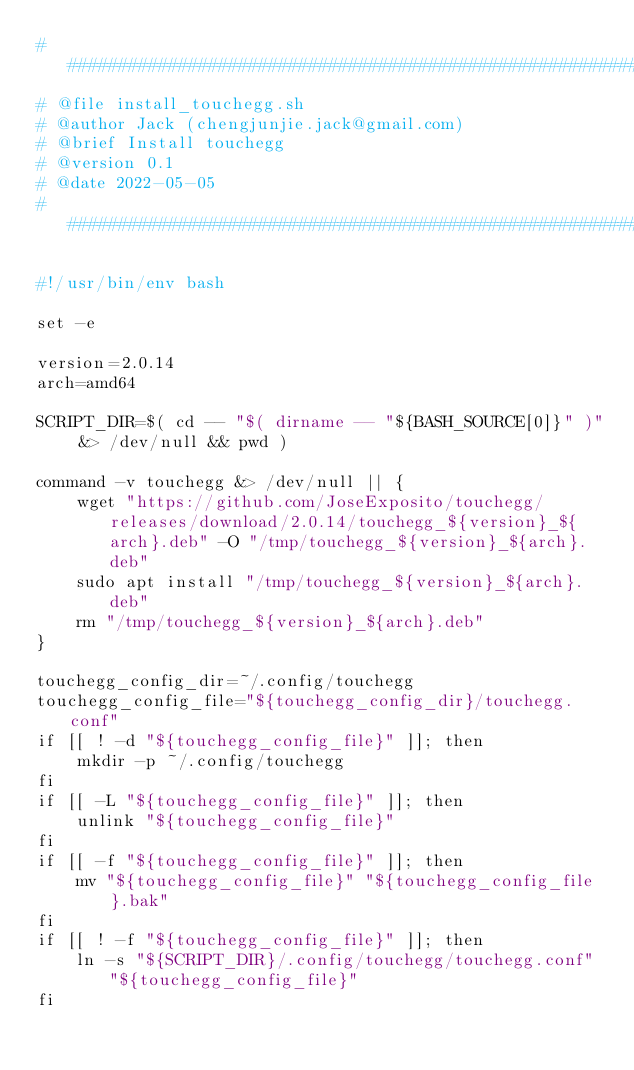<code> <loc_0><loc_0><loc_500><loc_500><_Bash_>##########################################################################
# @file install_touchegg.sh
# @author Jack (chengjunjie.jack@gmail.com)
# @brief Install touchegg
# @version 0.1
# @date 2022-05-05
#########################################################################

#!/usr/bin/env bash

set -e

version=2.0.14
arch=amd64

SCRIPT_DIR=$( cd -- "$( dirname -- "${BASH_SOURCE[0]}" )" &> /dev/null && pwd )

command -v touchegg &> /dev/null || {
    wget "https://github.com/JoseExposito/touchegg/releases/download/2.0.14/touchegg_${version}_${arch}.deb" -O "/tmp/touchegg_${version}_${arch}.deb"
    sudo apt install "/tmp/touchegg_${version}_${arch}.deb"
    rm "/tmp/touchegg_${version}_${arch}.deb"
}

touchegg_config_dir=~/.config/touchegg
touchegg_config_file="${touchegg_config_dir}/touchegg.conf"
if [[ ! -d "${touchegg_config_file}" ]]; then
    mkdir -p ~/.config/touchegg
fi
if [[ -L "${touchegg_config_file}" ]]; then
    unlink "${touchegg_config_file}"
fi
if [[ -f "${touchegg_config_file}" ]]; then
    mv "${touchegg_config_file}" "${touchegg_config_file}.bak"
fi
if [[ ! -f "${touchegg_config_file}" ]]; then
    ln -s "${SCRIPT_DIR}/.config/touchegg/touchegg.conf" "${touchegg_config_file}"
fi</code> 